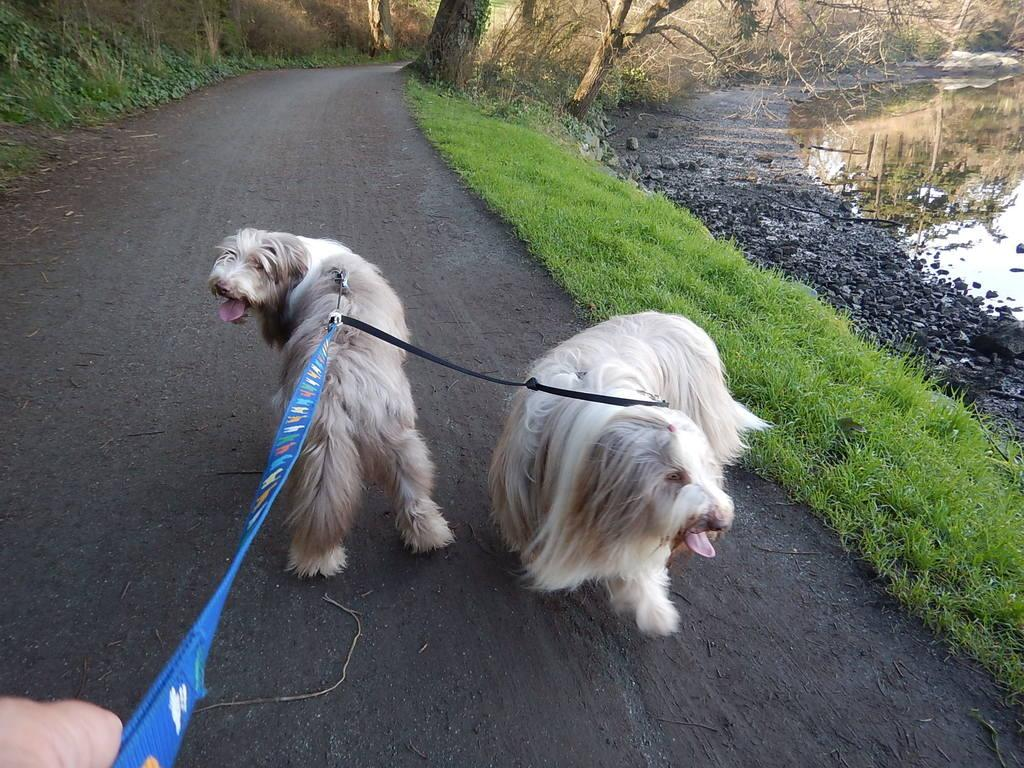What is the person in the image doing with the dogs? The person is holding dogs with a lease in the image. Where are the dogs and the person located? The dogs and the person are on a mud road in the image. What type of vegetation can be seen in the image? There is grass, plants, and the bark of trees visible in the image. What other elements can be seen in the image? There are stones and water visible in the image. What type of sponge is being used to clean the glass in the image? There is no sponge or glass present in the image; it features a person holding dogs with a lease on a mud road. 